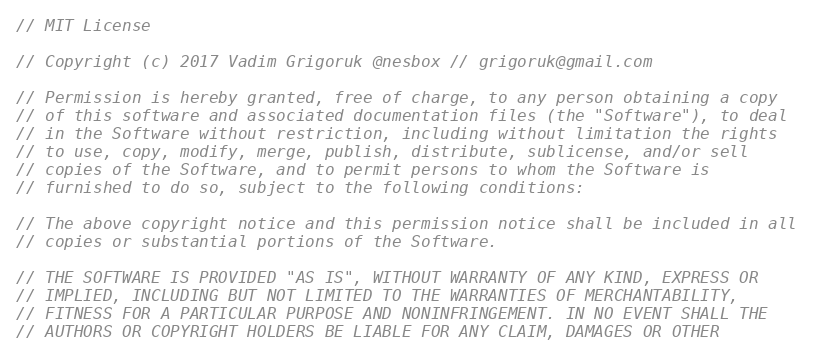<code> <loc_0><loc_0><loc_500><loc_500><_C_>// MIT License

// Copyright (c) 2017 Vadim Grigoruk @nesbox // grigoruk@gmail.com

// Permission is hereby granted, free of charge, to any person obtaining a copy
// of this software and associated documentation files (the "Software"), to deal
// in the Software without restriction, including without limitation the rights
// to use, copy, modify, merge, publish, distribute, sublicense, and/or sell
// copies of the Software, and to permit persons to whom the Software is
// furnished to do so, subject to the following conditions:

// The above copyright notice and this permission notice shall be included in all
// copies or substantial portions of the Software.

// THE SOFTWARE IS PROVIDED "AS IS", WITHOUT WARRANTY OF ANY KIND, EXPRESS OR
// IMPLIED, INCLUDING BUT NOT LIMITED TO THE WARRANTIES OF MERCHANTABILITY,
// FITNESS FOR A PARTICULAR PURPOSE AND NONINFRINGEMENT. IN NO EVENT SHALL THE
// AUTHORS OR COPYRIGHT HOLDERS BE LIABLE FOR ANY CLAIM, DAMAGES OR OTHER</code> 